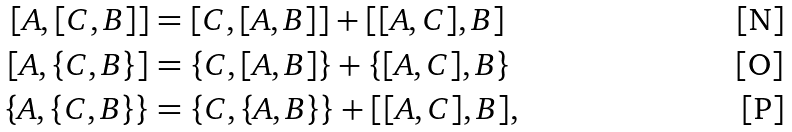Convert formula to latex. <formula><loc_0><loc_0><loc_500><loc_500>[ A , [ C , B ] ] & = [ C , [ A , B ] ] + [ [ A , C ] , B ] \\ [ A , \{ C , B \} ] & = \{ C , [ A , B ] \} + \{ [ A , C ] , B \} \\ \{ A , \{ C , B \} \} & = \{ C , \{ A , B \} \} + [ [ A , C ] , B ] ,</formula> 